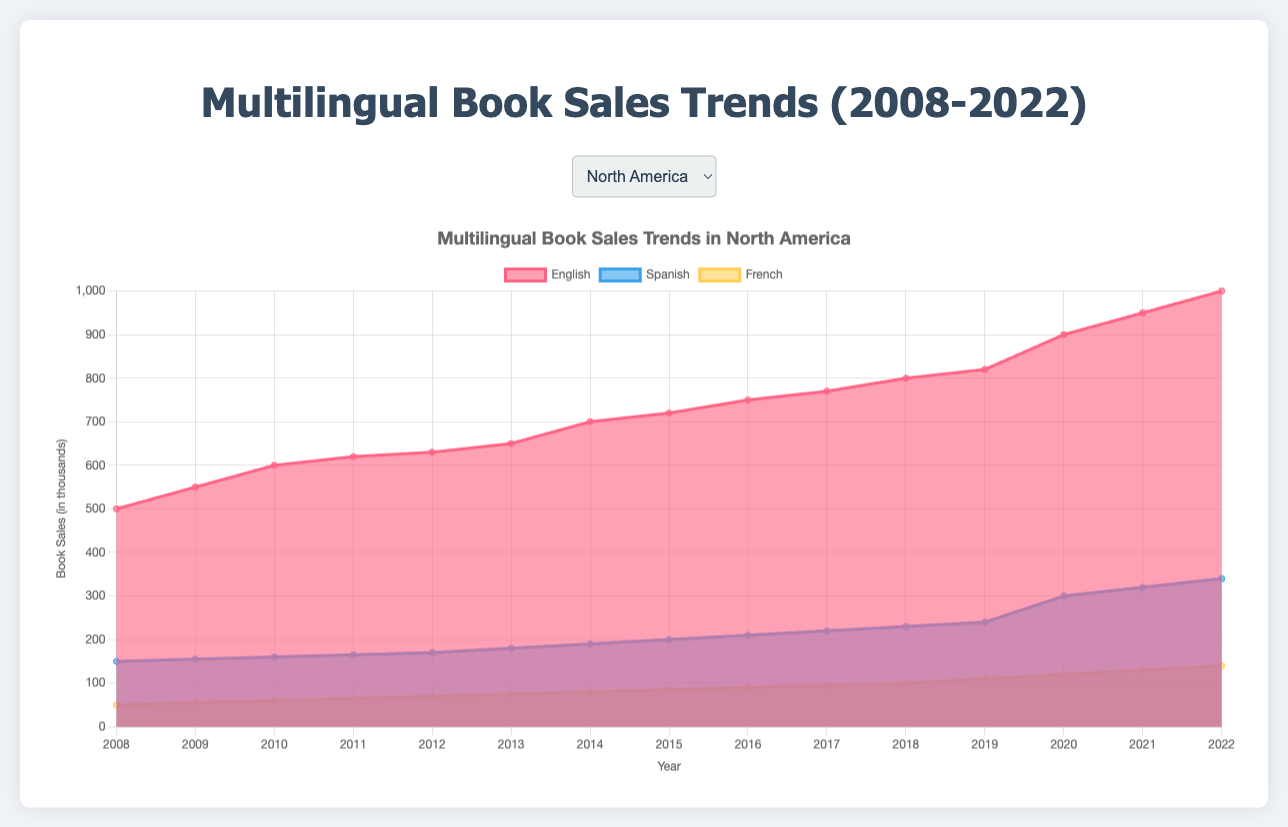What is the title of the chart? The title of the chart can be found at the top-center above the chart area. It provides a brief description of what the chart represents.
Answer: Multilingual Book Sales Trends (2008-2022) What does the y-axis represent in the chart? The y-axis represents the numerical values measured in the chart. In this case, it denotes the book sales in thousands.
Answer: Book Sales (in thousands) Which year shows the highest sales of Spanish books in North America? By looking at the Spanish sales data in North America within the chart and identifying the year with the highest value. The increase in sales is clearly visible in 2022.
Answer: 2022 Compare the trend of English book sales in North America and Europe. Which region shows a steeper increase over the years? Examine the slopes of the lines representing English book sales in both regions. North America shows a steeper slope from 2008 to 2022 compared to Europe.
Answer: North America By how much did Chinese book sales in Asia increase from 2008 to 2022? Look at the starting value for Chinese book sales in 2008 and the ending value in 2022. Subtract the former from the latter (1000 - 600).
Answer: 400 In which region did Spanish books have the smallest growth over the past 15 years? Compare the growth of Spanish books across all regions by identifying the differences between 2008 and 2022 values. Europe has the smallest growth from 100 to 190.
Answer: Europe What is the average annual increase in sales for Japanese books in Asia from 2008 to 2022? Subtract the sales value of 2008 from 2022 for Japanese books. Divide the result by the number of years (480 - 300 = 180, then 180 / 14).
Answer: 12.86 What year did French book sales in Europe surpass 450,000? Look at the French sales in Europe over the years and identify when the value first exceeds 450,000. This happens in 2017.
Answer: 2017 How do English book sales in Latin America in 2021 compare to Spanish book sales in North America in the same year? Find the sales figures for English books in Latin America and Spanish books in North America for 2021 (150 and 320 respectively). Then compare the two values (150 < 320).
Answer: Spanish book sales in North America were higher Which language had the most consistent growth in North America? By examining the regional languages in North America, focus on the language with an almost linear growth without abrupt changes. English book sales show a consistent trend.
Answer: English 